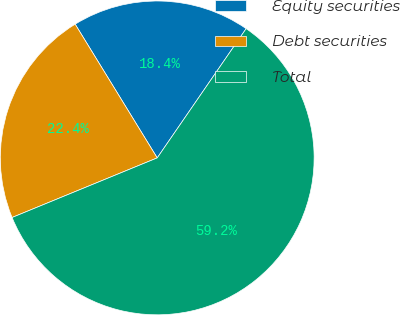<chart> <loc_0><loc_0><loc_500><loc_500><pie_chart><fcel>Equity securities<fcel>Debt securities<fcel>Total<nl><fcel>18.35%<fcel>22.44%<fcel>59.21%<nl></chart> 